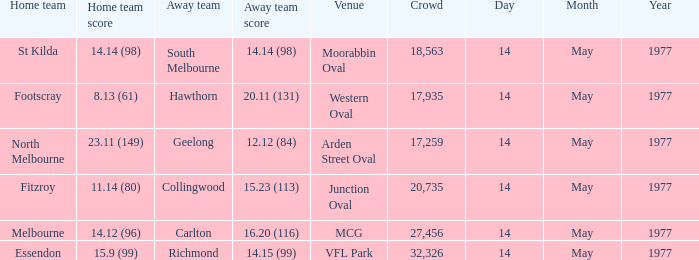Specify the visiting team against essendon. Richmond. Can you parse all the data within this table? {'header': ['Home team', 'Home team score', 'Away team', 'Away team score', 'Venue', 'Crowd', 'Day', 'Month', 'Year'], 'rows': [['St Kilda', '14.14 (98)', 'South Melbourne', '14.14 (98)', 'Moorabbin Oval', '18,563', '14', 'May', '1977'], ['Footscray', '8.13 (61)', 'Hawthorn', '20.11 (131)', 'Western Oval', '17,935', '14', 'May', '1977'], ['North Melbourne', '23.11 (149)', 'Geelong', '12.12 (84)', 'Arden Street Oval', '17,259', '14', 'May', '1977'], ['Fitzroy', '11.14 (80)', 'Collingwood', '15.23 (113)', 'Junction Oval', '20,735', '14', 'May', '1977'], ['Melbourne', '14.12 (96)', 'Carlton', '16.20 (116)', 'MCG', '27,456', '14', 'May', '1977'], ['Essendon', '15.9 (99)', 'Richmond', '14.15 (99)', 'VFL Park', '32,326', '14', 'May', '1977']]} 